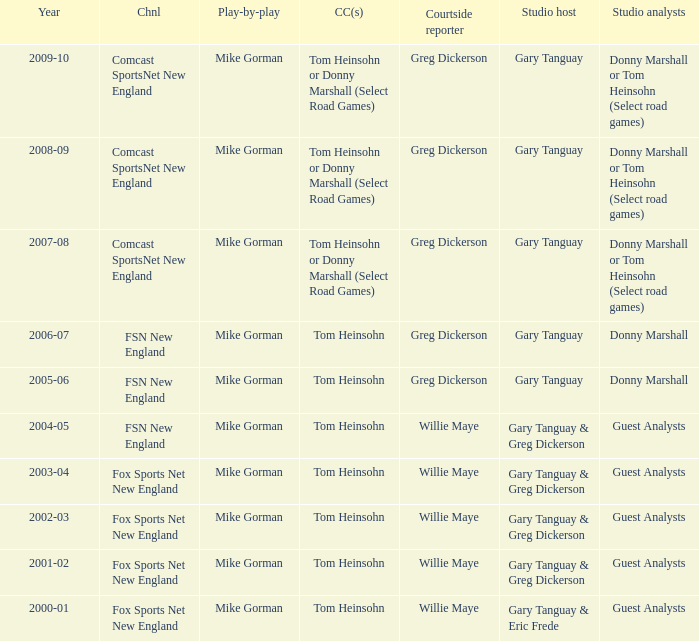WHich Play-by-play has a Studio host of gary tanguay, and a Studio analysts of donny marshall? Mike Gorman, Mike Gorman. 